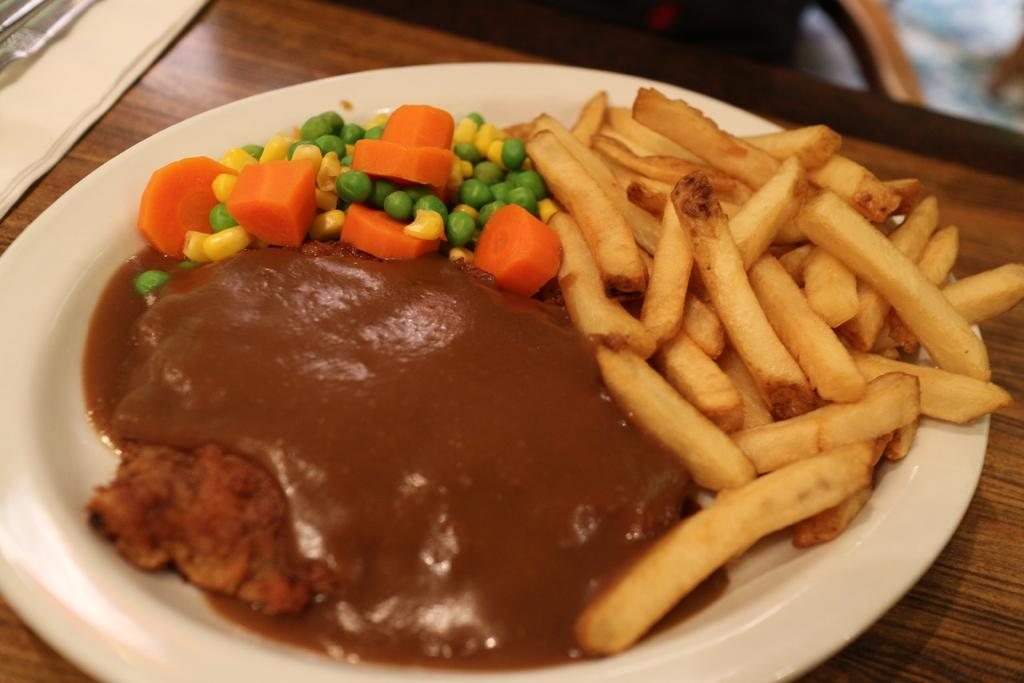What type of surface is visible in the image? There is a wooden surface in the image. What is placed on the wooden surface? There is a white plate on the wooden surface. What types of food can be seen on the plate? The plate contains fence fries, slices of carrot, corn grains, peas, and chutney. How does the plate expand to accommodate all the food in the image? The plate does not expand in the image; it is a fixed size and contains a variety of food items. Can you tell me about the sea trip depicted in the image? There is no sea trip or any reference to a trip in the image; it features a wooden surface with a plate of food. 